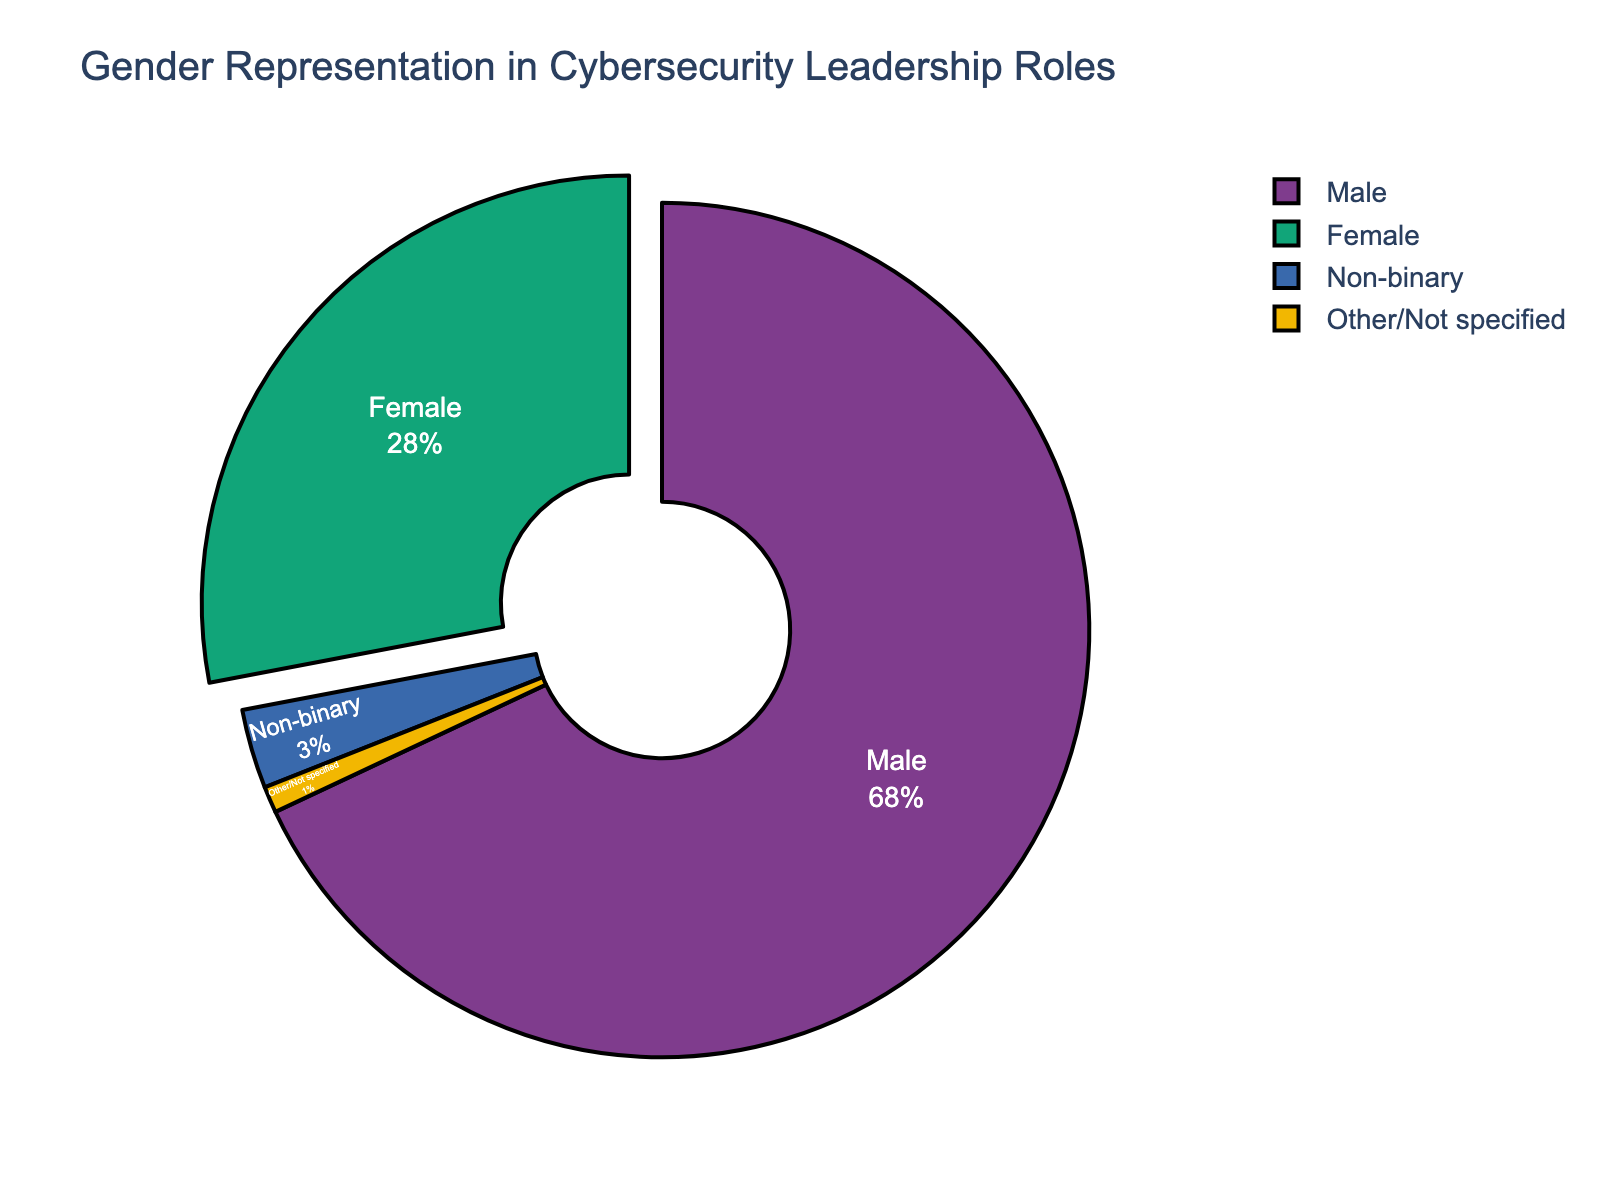What percentage of the cybersecurity leadership roles are represented by men? The pie chart shows four segments representing different genders. The segment for "Male" is labeled with its percentage.
Answer: 68% What is the combined percentage for non-binary and other/not specified gender representations in the cybersecurity leadership roles? We add the percentages for "Non-binary" (3%) and "Other/Not specified" (1%) to find the combined percentage.
Answer: 4% What is the difference in percentage between males and females in cybersecurity leadership roles? Subtract the percentage of females (28%) from the percentage of males (68%) to find the difference.
Answer: 40% Which gender representation segment is highlighted or popped out in the pie chart? The "Female" segment is visually highlighted by being pulled out from the pie chart, making it more prominent.
Answer: Female How does the percentage of females compare to the percentage of males in the cybersecurity leadership roles? Comparing the percentages, the males (68%) have a significantly higher representation than females (28%).
Answer: Males have a higher representation By how many percentage points does the male representation exceed the total of all other gender representations combined? First, we add the percentages of females (28%), non-binary (3%), and other/not specified (1%) to get 32%. Then, subtract this from the male percentage (68%).
Answer: 36% What is the visual color used to represent the female gender in the pie chart? Observing the segment labeled "Female," we note that its color stands out distinctly.
Answer: Red (assuming red to be the standout color, you may need to verify this based on the actual visual) Which gender has the least representation in cybersecurity leadership roles according to the pie chart? Based on the percentage values, the "Other/Not specified" category has the smallest value (1%).
Answer: Other/Not specified What is the combined percentage of male and female representatives in cybersecurity leadership roles? Add the percentage of males (68%) and females (28%) to get the combined percentage.
Answer: 96% 